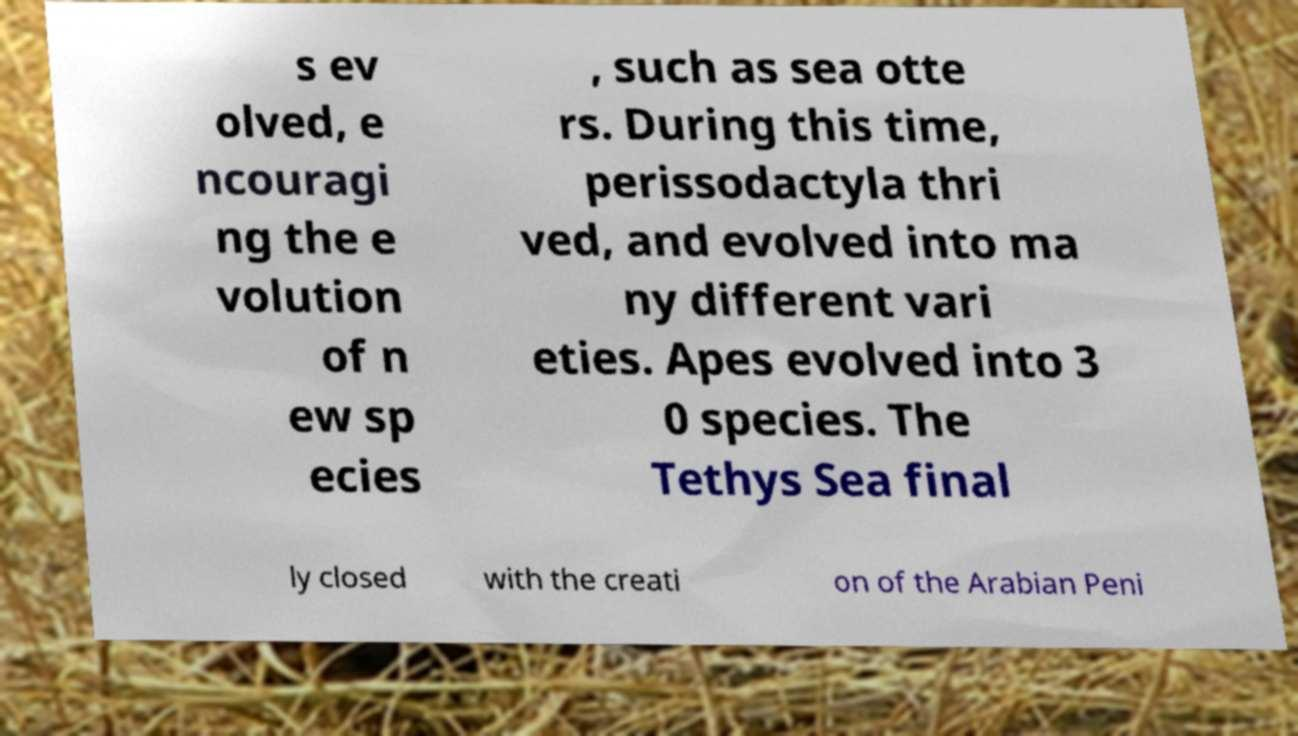Please read and relay the text visible in this image. What does it say? s ev olved, e ncouragi ng the e volution of n ew sp ecies , such as sea otte rs. During this time, perissodactyla thri ved, and evolved into ma ny different vari eties. Apes evolved into 3 0 species. The Tethys Sea final ly closed with the creati on of the Arabian Peni 